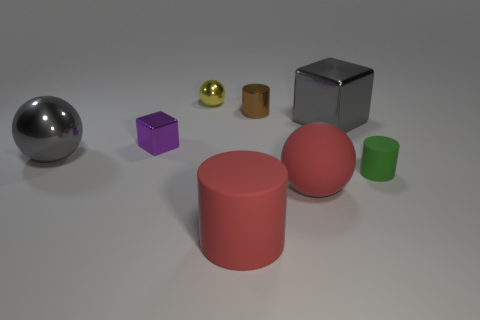Subtract all big gray balls. How many balls are left? 2 Subtract 1 blocks. How many blocks are left? 1 Subtract all purple blocks. How many blocks are left? 1 Add 2 small green rubber cylinders. How many objects exist? 10 Subtract all spheres. How many objects are left? 5 Add 7 tiny balls. How many tiny balls exist? 8 Subtract 1 purple blocks. How many objects are left? 7 Subtract all gray cylinders. Subtract all yellow cubes. How many cylinders are left? 3 Subtract all small cylinders. Subtract all gray metallic blocks. How many objects are left? 5 Add 3 gray metallic spheres. How many gray metallic spheres are left? 4 